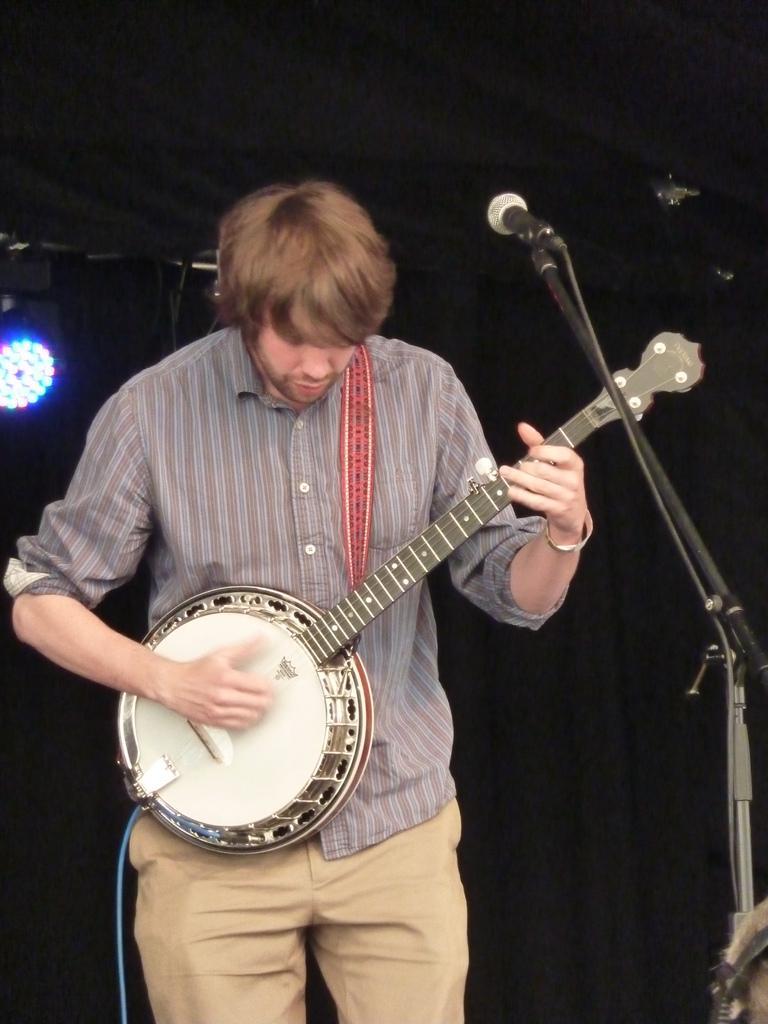Describe this image in one or two sentences. In the picture there is a man standing and playing a musical instrument, in front of the man there is a microphone with the stand, there is a cable attached to the microphone, behind the man there is a light. 